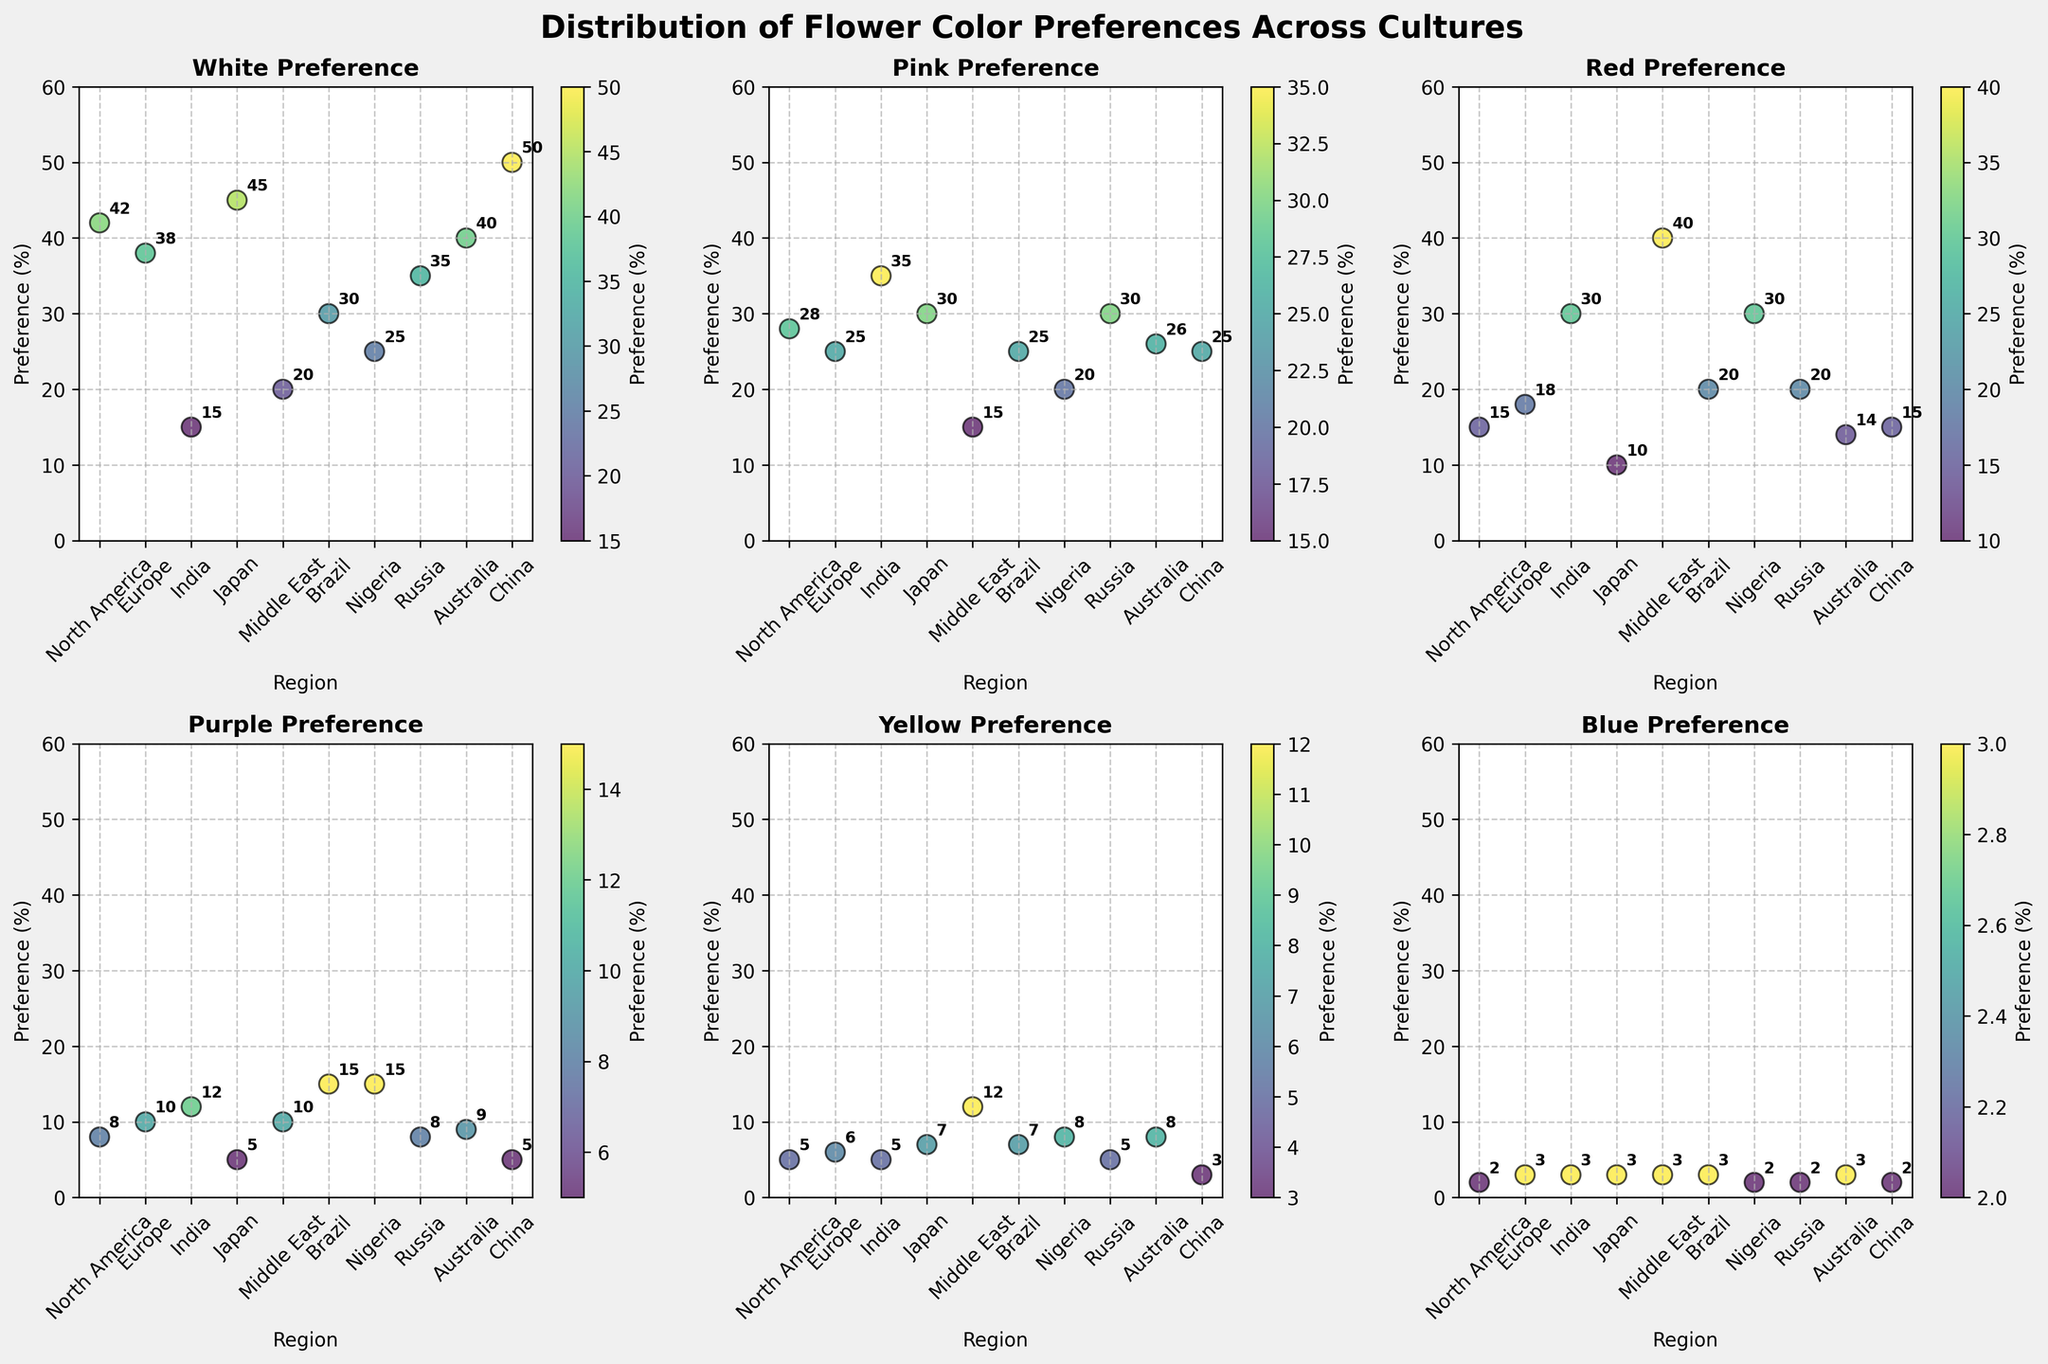What is the title of the figure? The title of the figure is located at the very top and is written in bold font.
Answer: Distribution of Flower Color Preferences Across Cultures Which region has the highest preference for white flowers? By examining the plot for white preference, the data point with the highest value is in the East Asian region, specifically Japan or China.
Answer: China What is the average preference for pink flowers across all regions? Sum all the pink preferences from the plot and divide by the number of regions, (28+25+35+30+15+25+20+30+26+25)/10. The result is the average value.
Answer: 25.9 Which culture has the lowest preference for blue flowers? By checking the blue preference subplot, the smallest value is in the North America region (Western culture).
Answer: Western (North America) What is the comparison of red flower preferences between India and Brazil? For India, the preference is 30%, and for Brazil, it is 20%. Compare these two values to determine which is higher.
Answer: India has a higher preference than Brazil How many regions have a greater than 40% preference for white flowers? Identify data points in the white preference subplot that are greater than 40%. North America, Japan, Australia, and China meet this criterion.
Answer: 4 regions Which color has the widest range of preferences across all regions? Calculate the range (difference between the maximum and minimum values) for each color. The color with the largest difference is yellow (12-2).
Answer: Yellow What is the median preference percentage for purple flowers in all the regions? List out all the purple preferences (8, 10, 12, 5, 10, 15, 15, 8, 9, 5), then find the median by sorting and locating the middle value. Two middle values (8, 9), average 8 and 9 to get the median.
Answer: 9 Compare the pink flower preference between North America and Europe. The subplot for pink preference shows 28% for North America and 25% for Europe.
Answer: North America has a higher preference What regions have a lower preference for yellow flowers compared to purple flowers? Compare yellow and purple preferences in each region, identify regions where yellow preference is less than purple, such as Japan, Brazil, and Nigeria.
Answer: Japan, Brazil, Nigeria 